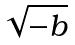<formula> <loc_0><loc_0><loc_500><loc_500>\sqrt { - b }</formula> 